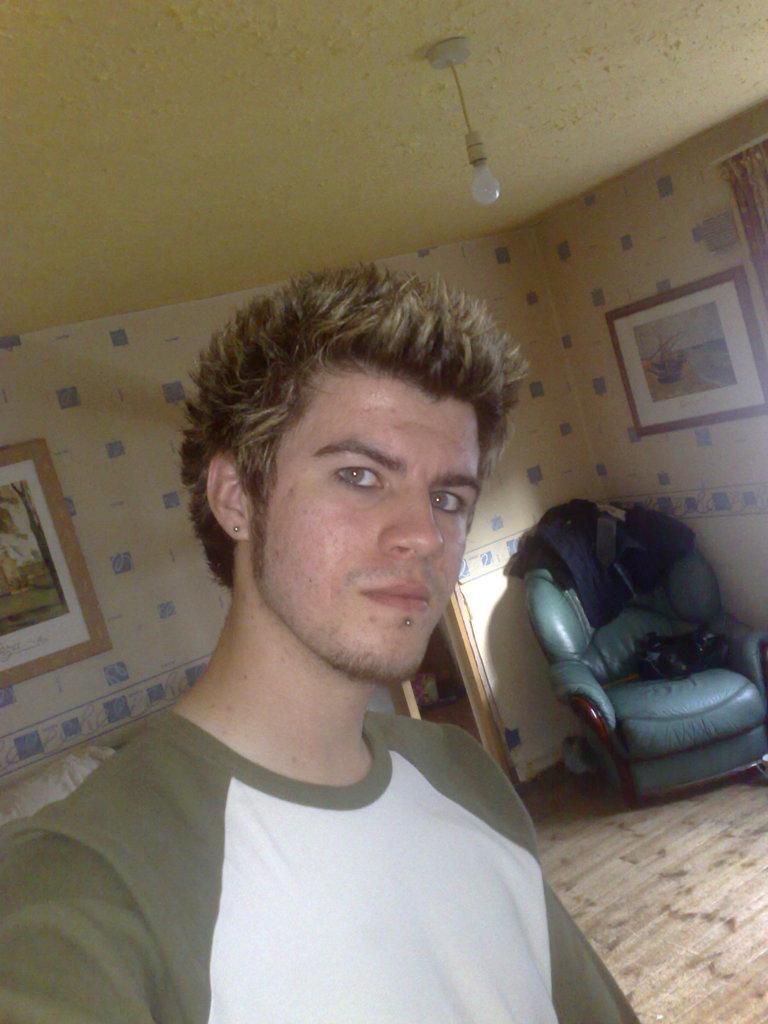Could you give a brief overview of what you see in this image? This is the picture of a room. In this picture there is a person standing. At the back there are clothes on the chair and there is a door and there are frames on the wall and there is a curtain. At the top there is a light. 